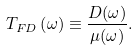<formula> <loc_0><loc_0><loc_500><loc_500>T _ { F D } \left ( \omega \right ) \equiv \frac { D ( \omega ) } { \mu ( \omega ) } .</formula> 